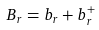<formula> <loc_0><loc_0><loc_500><loc_500>B _ { r } = b _ { r } + b _ { r } ^ { + }</formula> 